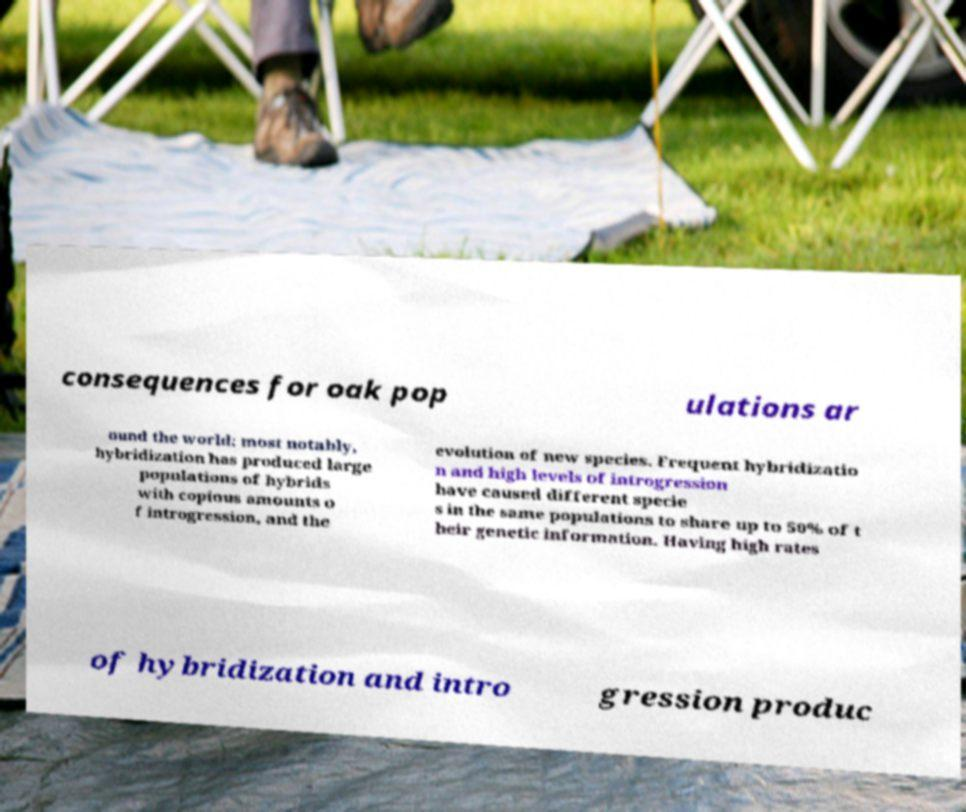Can you read and provide the text displayed in the image?This photo seems to have some interesting text. Can you extract and type it out for me? consequences for oak pop ulations ar ound the world; most notably, hybridization has produced large populations of hybrids with copious amounts o f introgression, and the evolution of new species. Frequent hybridizatio n and high levels of introgression have caused different specie s in the same populations to share up to 50% of t heir genetic information. Having high rates of hybridization and intro gression produc 